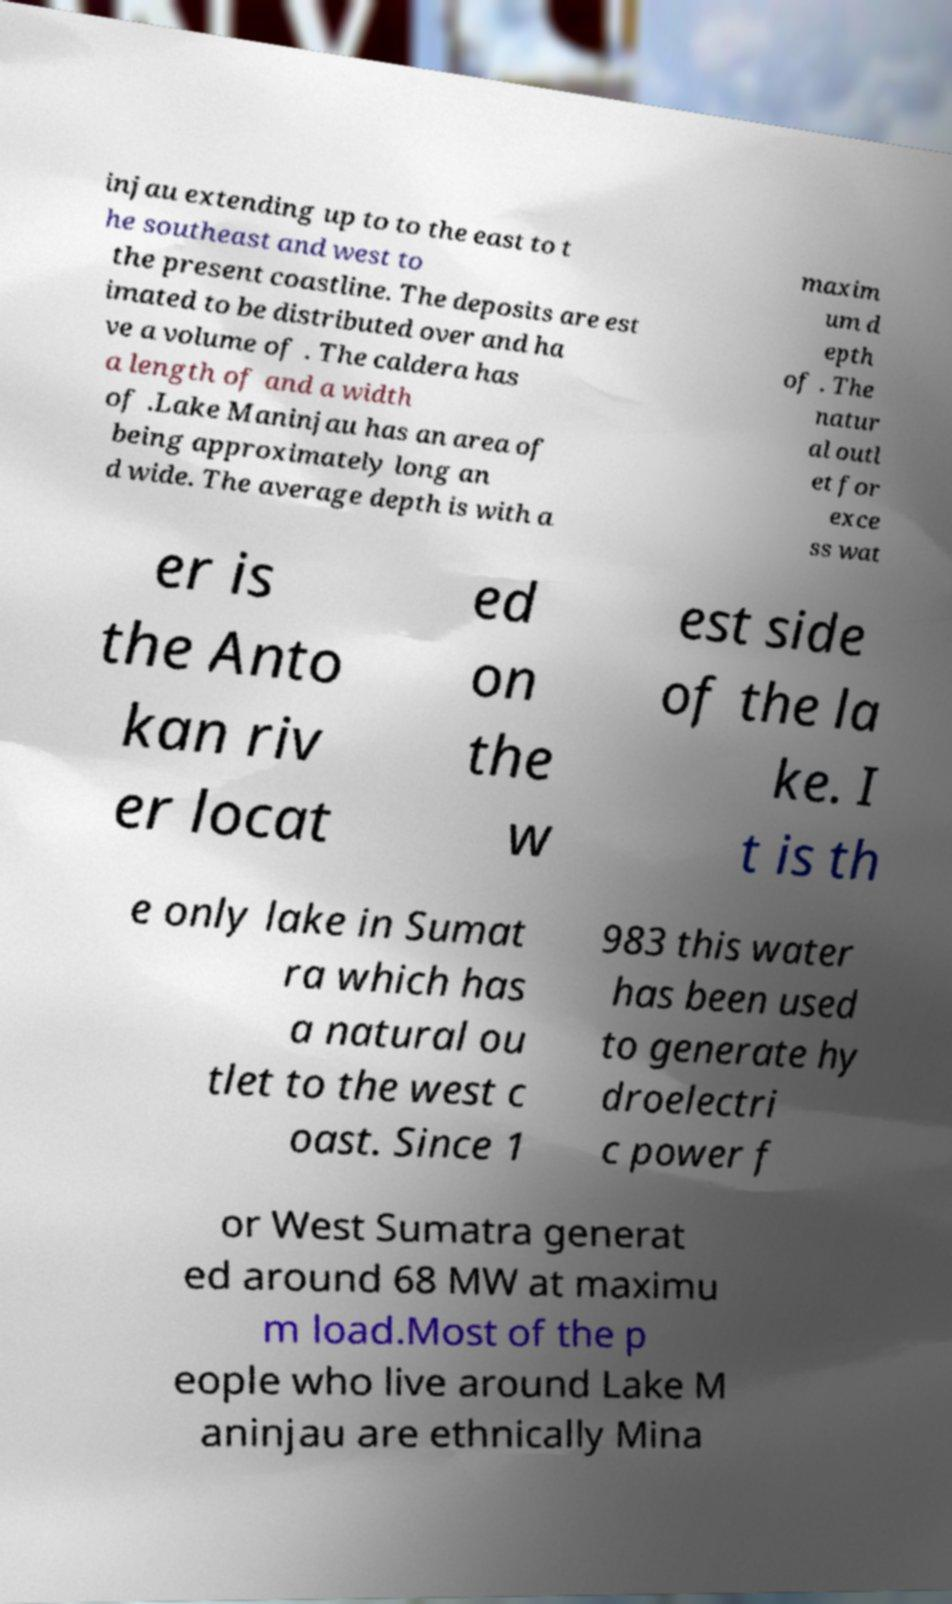Could you assist in decoding the text presented in this image and type it out clearly? injau extending up to to the east to t he southeast and west to the present coastline. The deposits are est imated to be distributed over and ha ve a volume of . The caldera has a length of and a width of .Lake Maninjau has an area of being approximately long an d wide. The average depth is with a maxim um d epth of . The natur al outl et for exce ss wat er is the Anto kan riv er locat ed on the w est side of the la ke. I t is th e only lake in Sumat ra which has a natural ou tlet to the west c oast. Since 1 983 this water has been used to generate hy droelectri c power f or West Sumatra generat ed around 68 MW at maximu m load.Most of the p eople who live around Lake M aninjau are ethnically Mina 